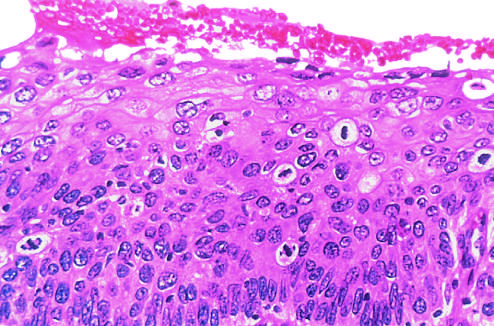what is not seen in this section?
Answer the question using a single word or phrase. The intact basement membrane 